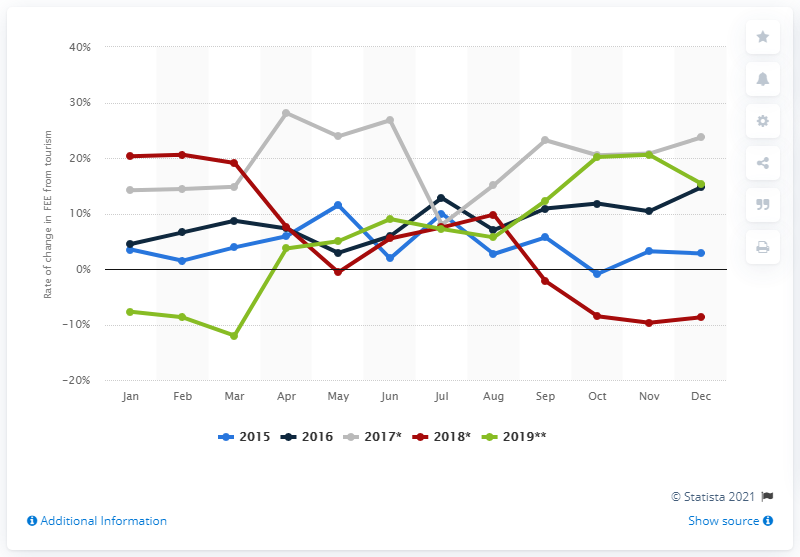Point out several critical features in this image. In November 2019, the foreign exchange earnings from tourism increased by 20.2% compared to the same period in the previous year. In December 2019, tourism earned 20.2 billion dollars in India. 